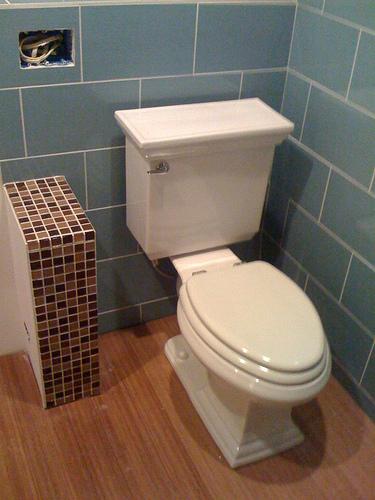Does this toilet tank surface need cleaning?
Keep it brief. No. What is the floor made of?
Give a very brief answer. Wood. Is the toilet lid up?
Write a very short answer. No. Does this room look dirty?
Short answer required. No. What kind of flooring is shown?
Give a very brief answer. Wood. What color is the tile behind the toilet?
Keep it brief. Blue. What kind of material is the floor made of?
Short answer required. Wood. 